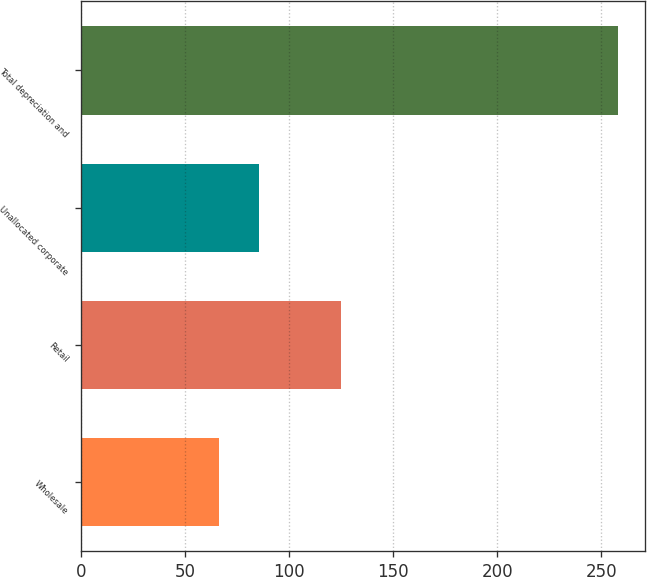Convert chart. <chart><loc_0><loc_0><loc_500><loc_500><bar_chart><fcel>Wholesale<fcel>Retail<fcel>Unallocated corporate<fcel>Total depreciation and<nl><fcel>66<fcel>125<fcel>85.2<fcel>258<nl></chart> 